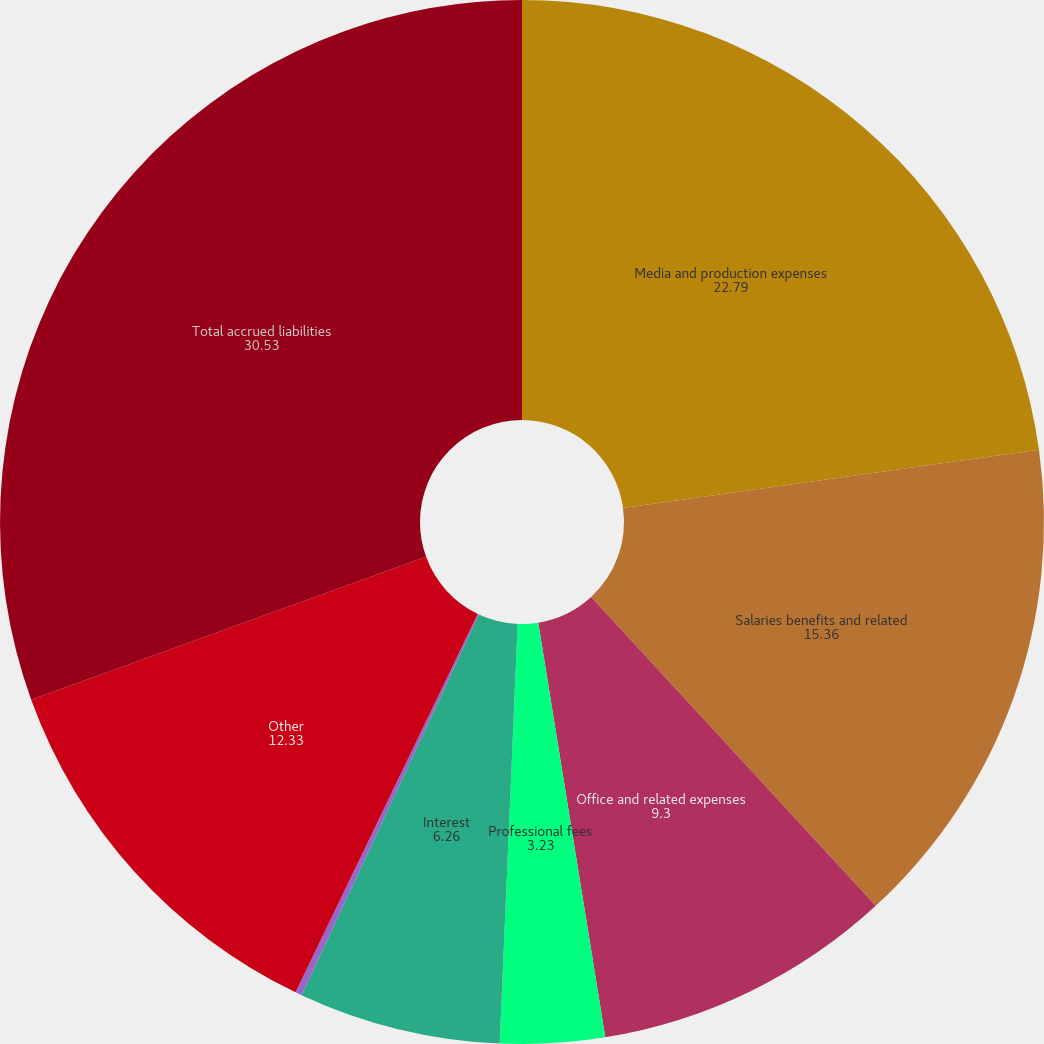Convert chart to OTSL. <chart><loc_0><loc_0><loc_500><loc_500><pie_chart><fcel>Media and production expenses<fcel>Salaries benefits and related<fcel>Office and related expenses<fcel>Professional fees<fcel>Interest<fcel>Acquisition obligations<fcel>Other<fcel>Total accrued liabilities<nl><fcel>22.79%<fcel>15.36%<fcel>9.3%<fcel>3.23%<fcel>6.26%<fcel>0.2%<fcel>12.33%<fcel>30.53%<nl></chart> 